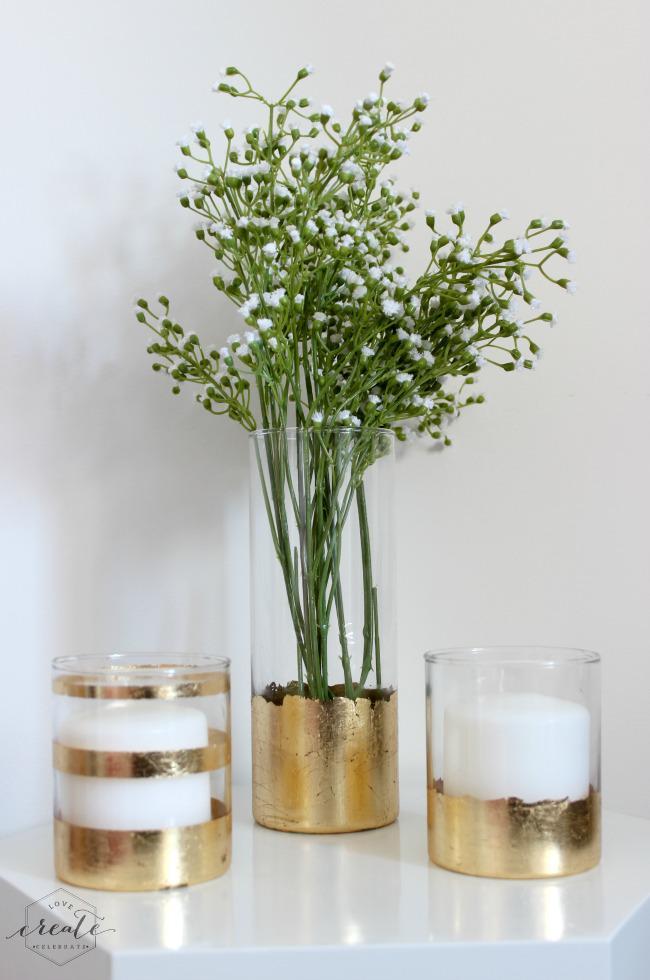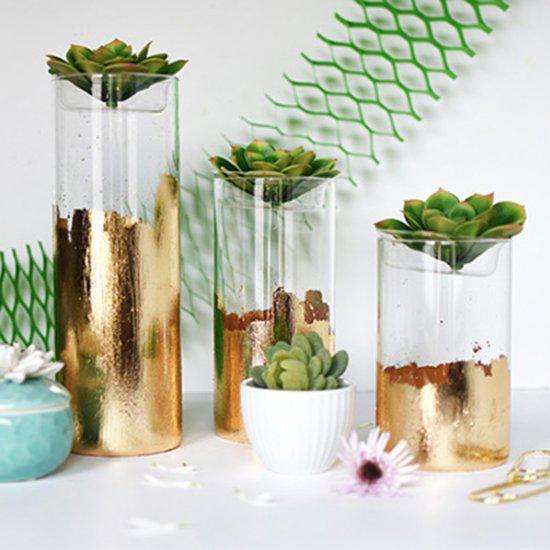The first image is the image on the left, the second image is the image on the right. For the images displayed, is the sentence "At least one planter has a succulent in it." factually correct? Answer yes or no. Yes. The first image is the image on the left, the second image is the image on the right. Evaluate the accuracy of this statement regarding the images: "Several plants sit in vases in the image on the right.". Is it true? Answer yes or no. Yes. 